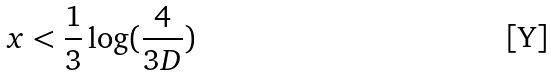<formula> <loc_0><loc_0><loc_500><loc_500>x < \frac { 1 } { 3 } \log ( \frac { 4 } { 3 D } )</formula> 